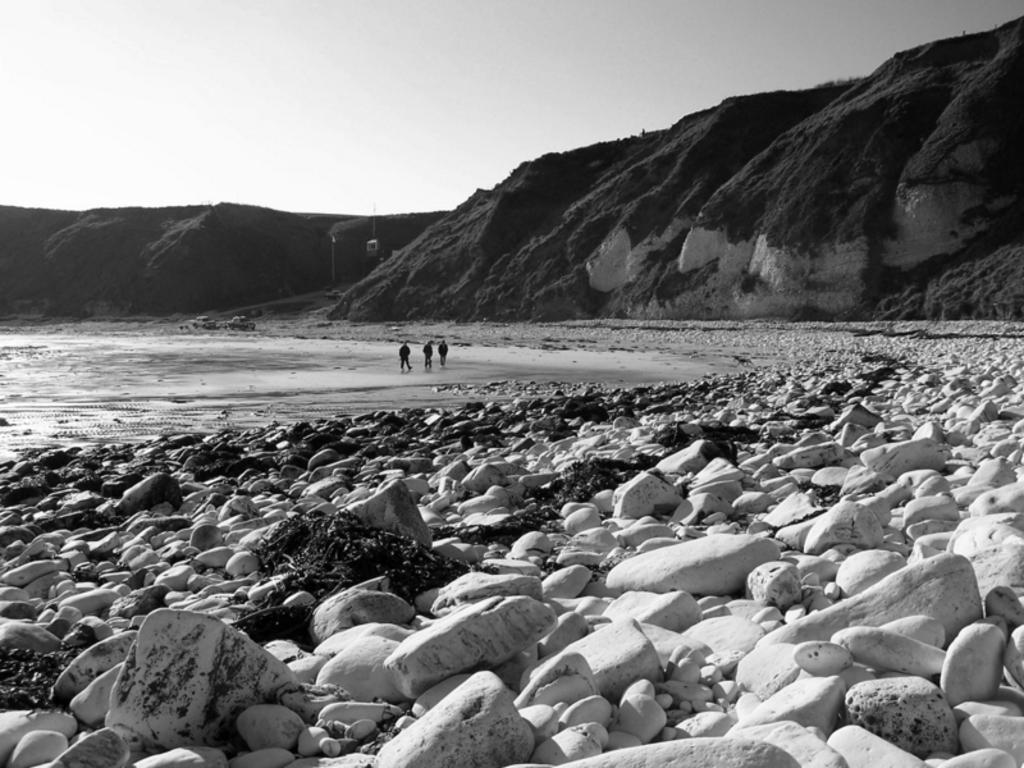What is the color scheme of the image? The image is black and white. Who or what can be seen in the image? There are persons in the image. What type of natural elements are present in the image? There are stones, water, hills, and the sky visible in the image. What direction are the dogs facing in the image? There are no dogs present in the image. What month is it in the image? The month cannot be determined from the image, as it only provides visual information and no context about the time of year. 